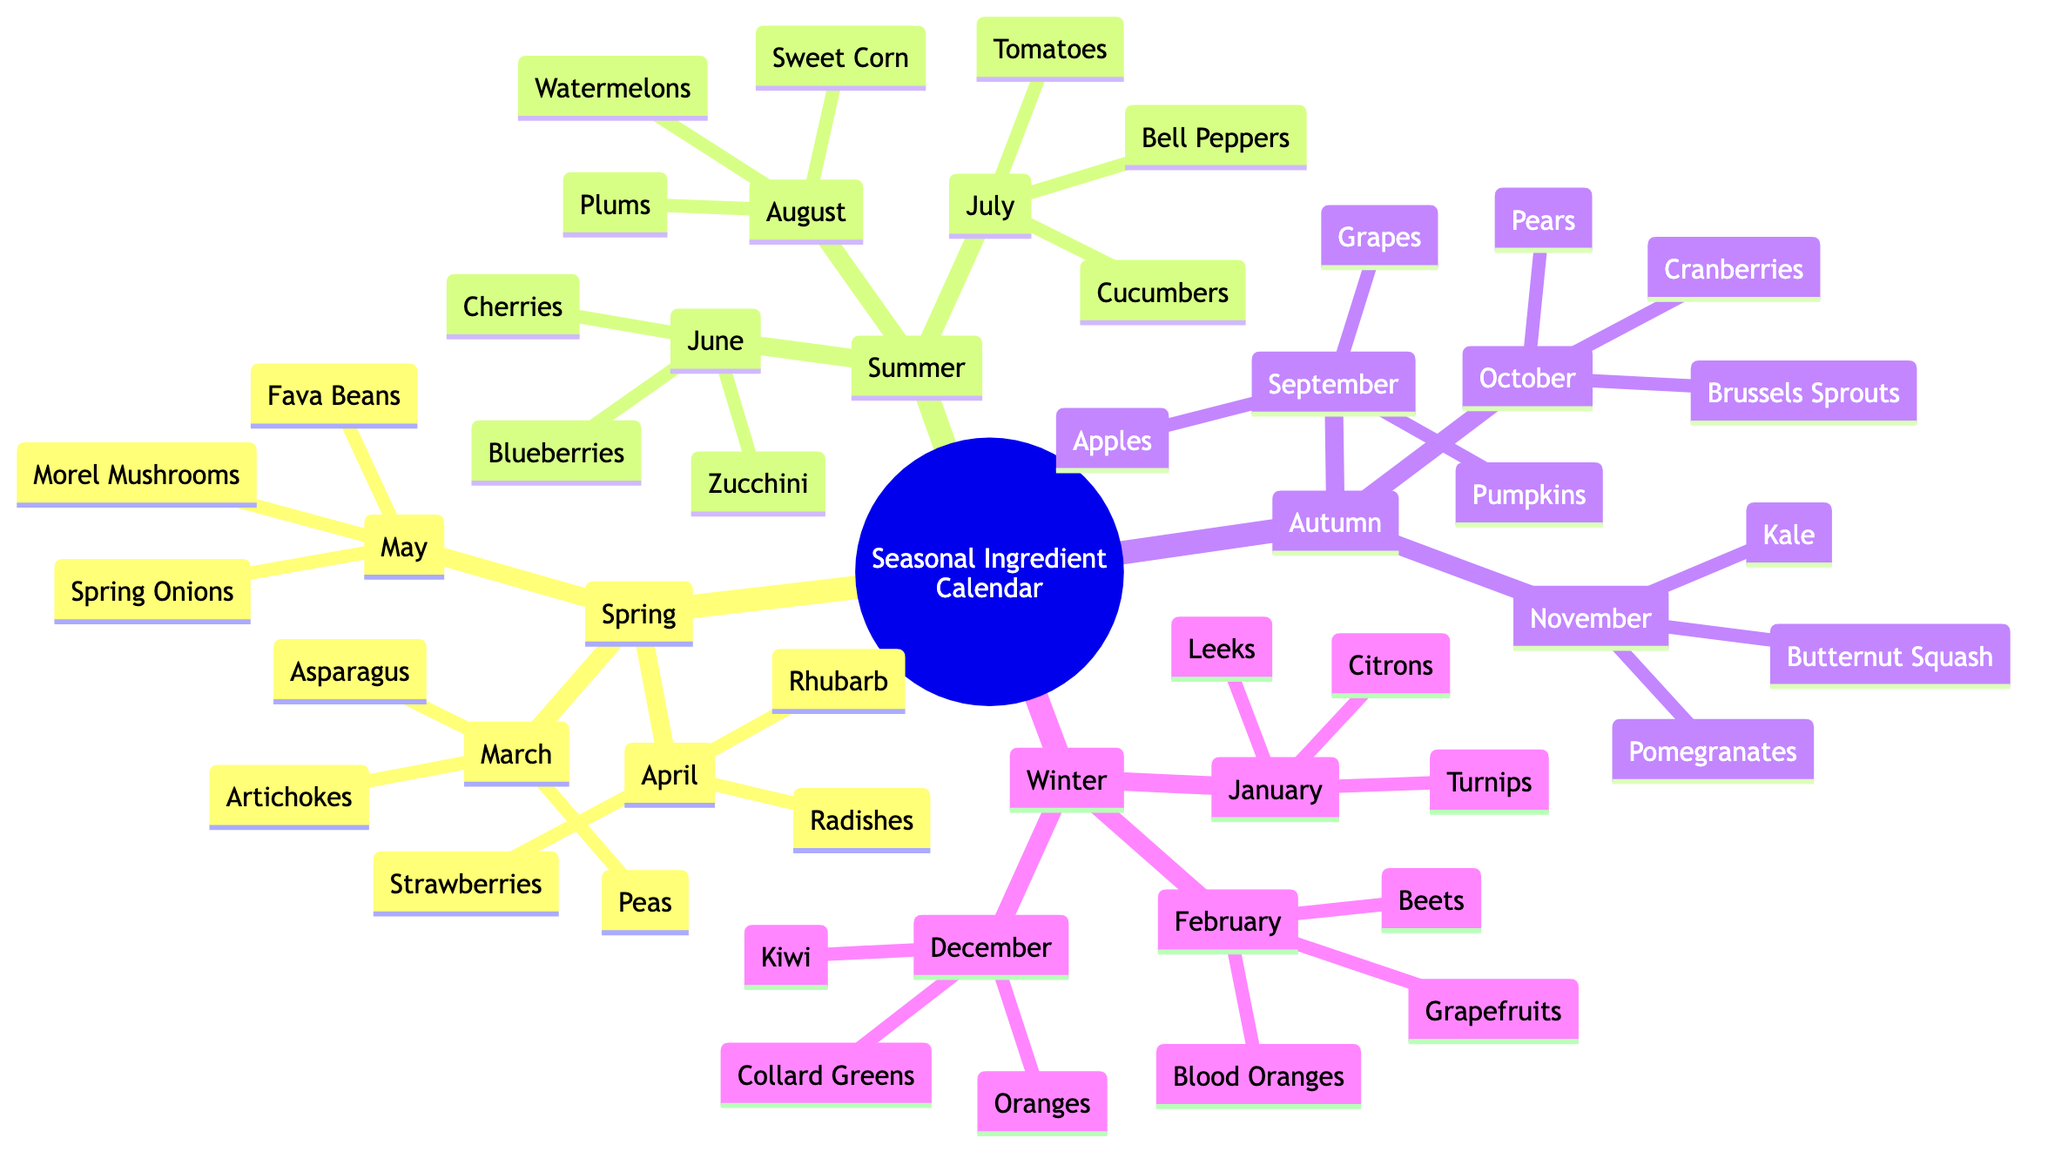What ingredients are available in March? In the Spring section under March, the ingredients listed are Artichokes, Asparagus, and Peas.
Answer: Artichokes, Asparagus, Peas How many ingredients are listed for August? In the Summer section under August, there are three ingredients: Plums, Watermelons, and Sweet Corn. Thus, the total count is three.
Answer: 3 Which month has both Rhubarb and Strawberries available? Looking in the Spring section for April, Rhubarb and Strawberries are both listed as available ingredients.
Answer: April What is the last month listed in the calendar? The calendar lists months in the sequence of Spring, Summer, Autumn, and Winter, with February being the last month mentioned under Winter.
Answer: February Which season features Morel Mushrooms? Morel Mushrooms are found in May, which is part of the Spring section of the diagram.
Answer: Spring In which month are both Grapes and Pumpkins available? Grapes are available in September and Pumpkins are available in September, making that month the common one for both ingredients.
Answer: September How many total seasonal categories are displayed in this calendar? The seasonal categories are Spring, Summer, Autumn, and Winter, totaling four distinct categories shown in the diagram.
Answer: 4 Count the number of ingredients listed under Winter and provide that count. Under Winter, the ingredients across December (3), January (3), and February (3) total to 3 + 3 + 3, which equals 9 ingredients listed overall for that season.
Answer: 9 What ingredients can be found in October? October features Pears, Brussels Sprouts, and Cranberries as the available ingredients according to the diagram.
Answer: Pears, Brussels Sprouts, Cranberries Which season has the ingredient Zucchini? Zucchini is mentioned in June, which falls under the Summer section, indicating that it is a summer ingredient.
Answer: Summer 